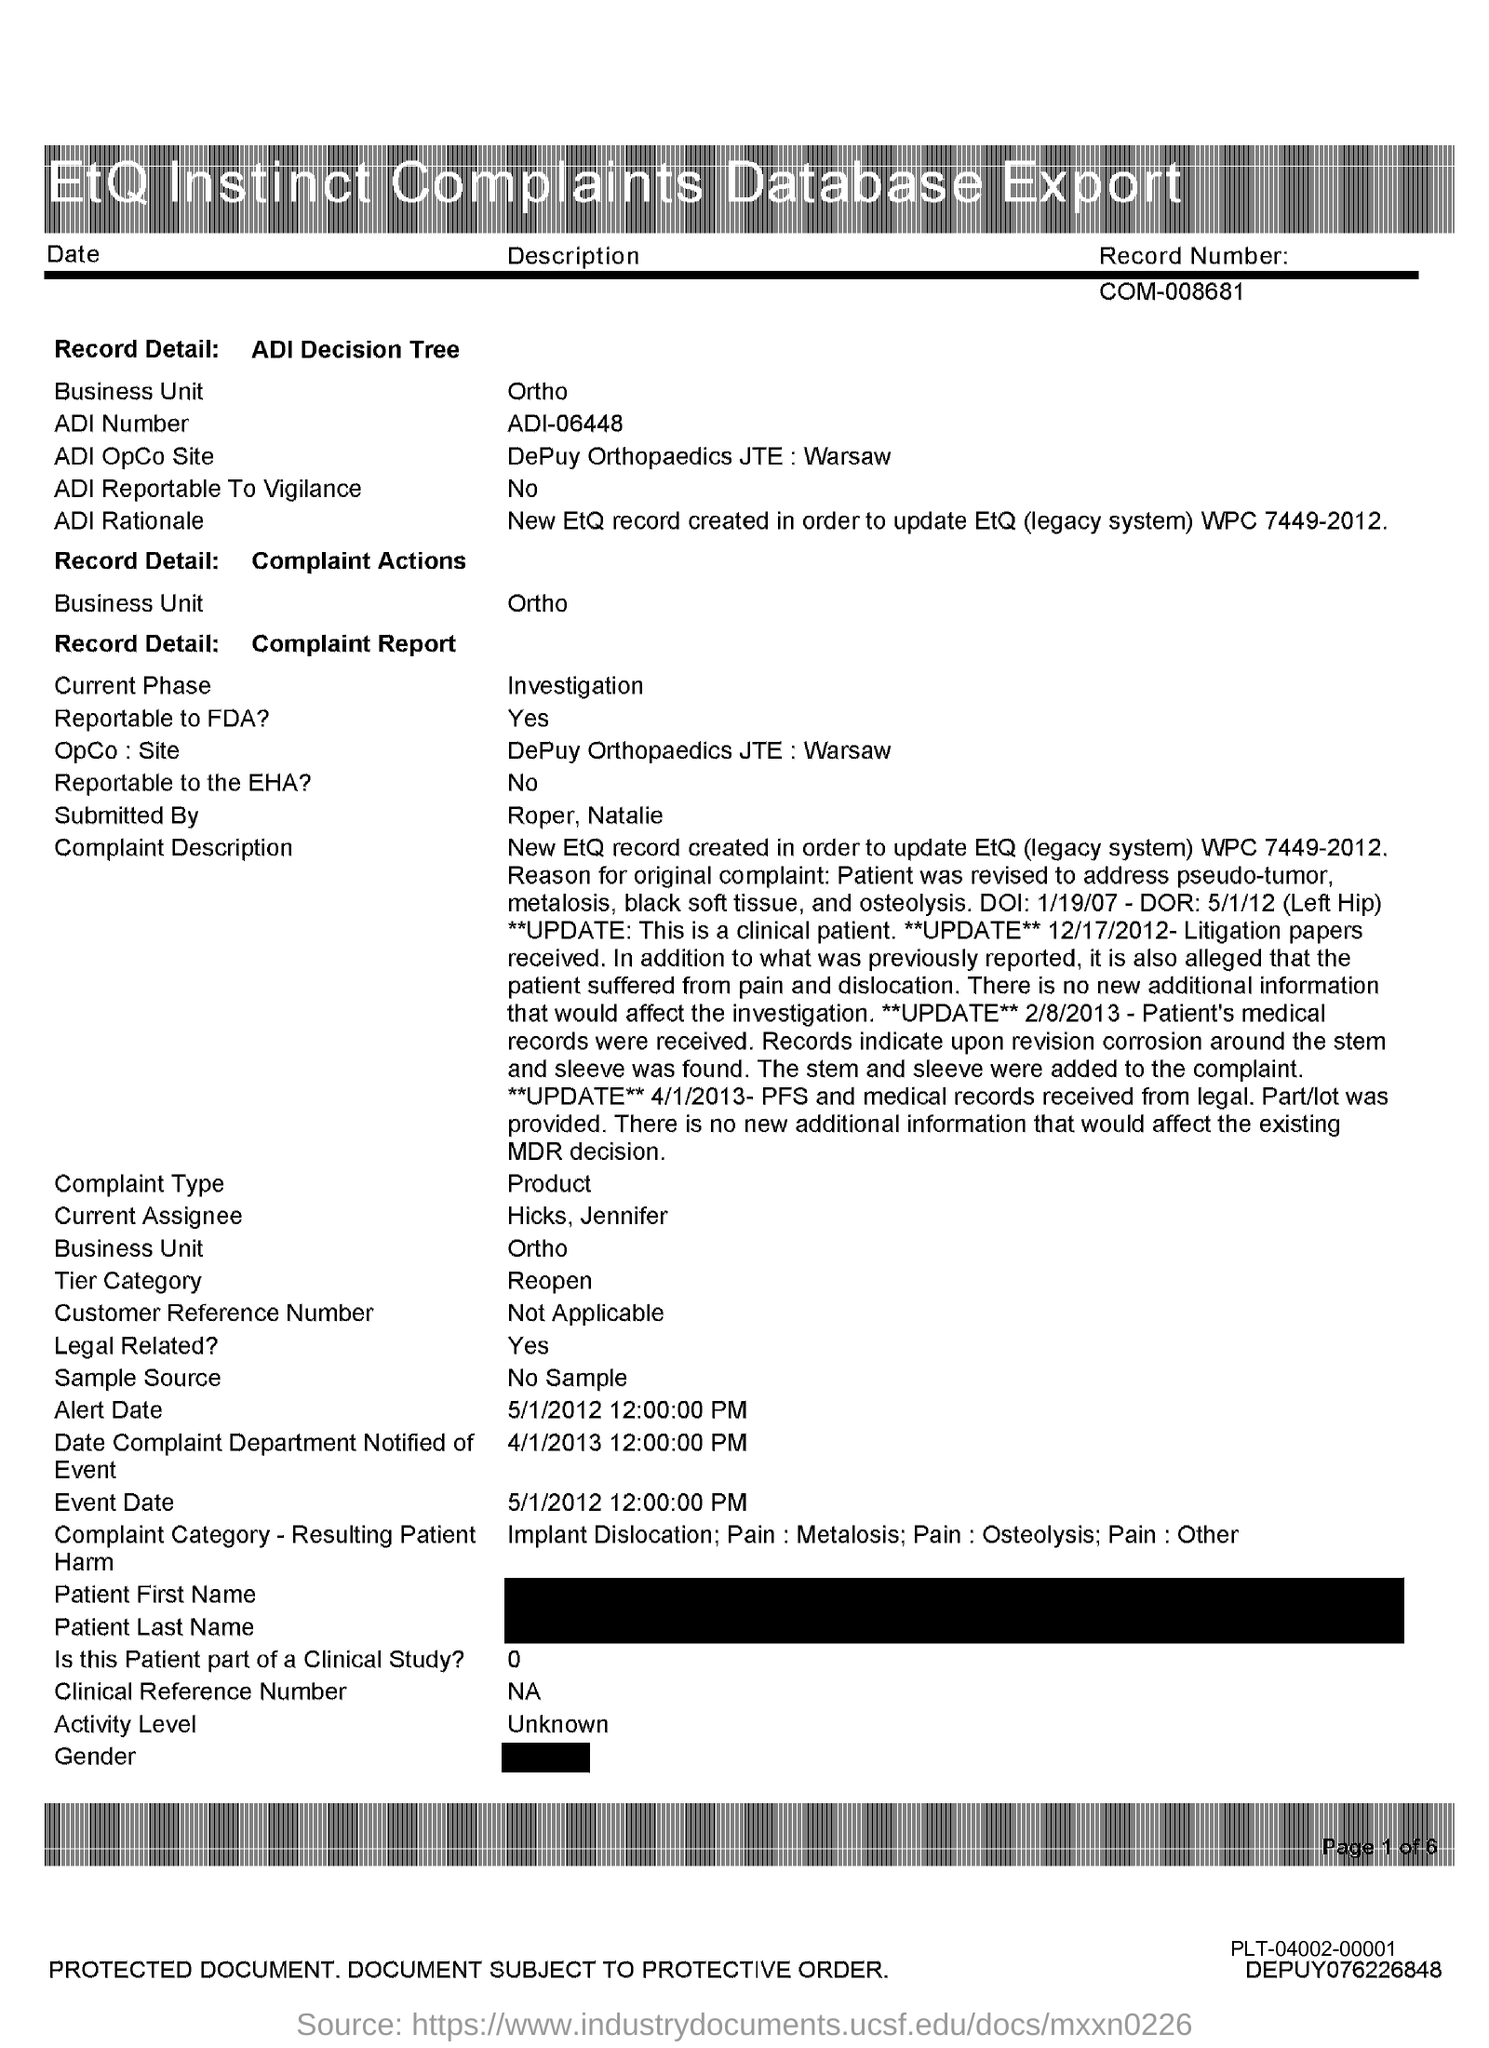What is the Business unit in the table?
Offer a very short reply. Ortho. What is the ADI Number in ADI Decision tree?
Keep it short and to the point. ADI-06448. What is the ADI OpCo Site in ADI Decision Tree?
Keep it short and to the point. DePuy Orthopaedics JTE : Warsaw. What is the Alert Date in Complaint Report?
Offer a terse response. 5/1/2012. What is the Event date in Complaint Report?
Offer a terse response. 5/1/2012. What is the OPCo: Site in the Complaint report?
Provide a short and direct response. DePuy Orthopaedics JTE:Warsaw. What is the Current phase in the Complaint report?
Offer a very short reply. Investigation. Who submitted the complaint report?
Provide a succinct answer. Roper,Natalie. Who is the Current Assignee in the Complaint report?
Your answer should be compact. Hicks,Jennifer. What is the heading of the table?
Your answer should be compact. EtQ Instinct Complaints Database Export. 